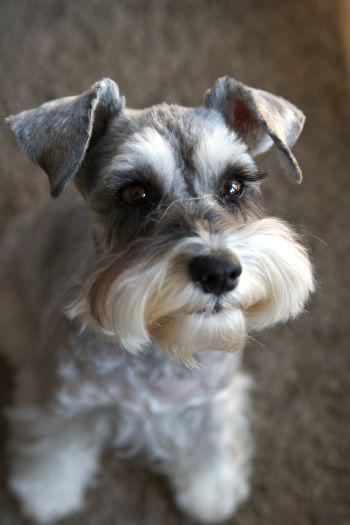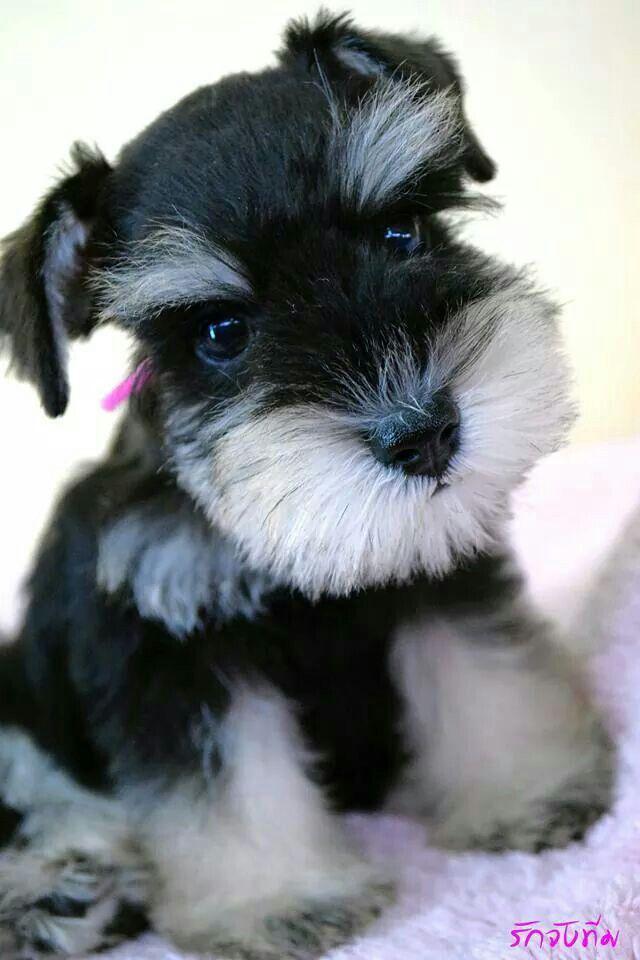The first image is the image on the left, the second image is the image on the right. Considering the images on both sides, is "Right image shows a dog looking upward, with mouth open." valid? Answer yes or no. No. The first image is the image on the left, the second image is the image on the right. Given the left and right images, does the statement "The dog in the right image has its mouth open as it stands in the grass." hold true? Answer yes or no. No. 